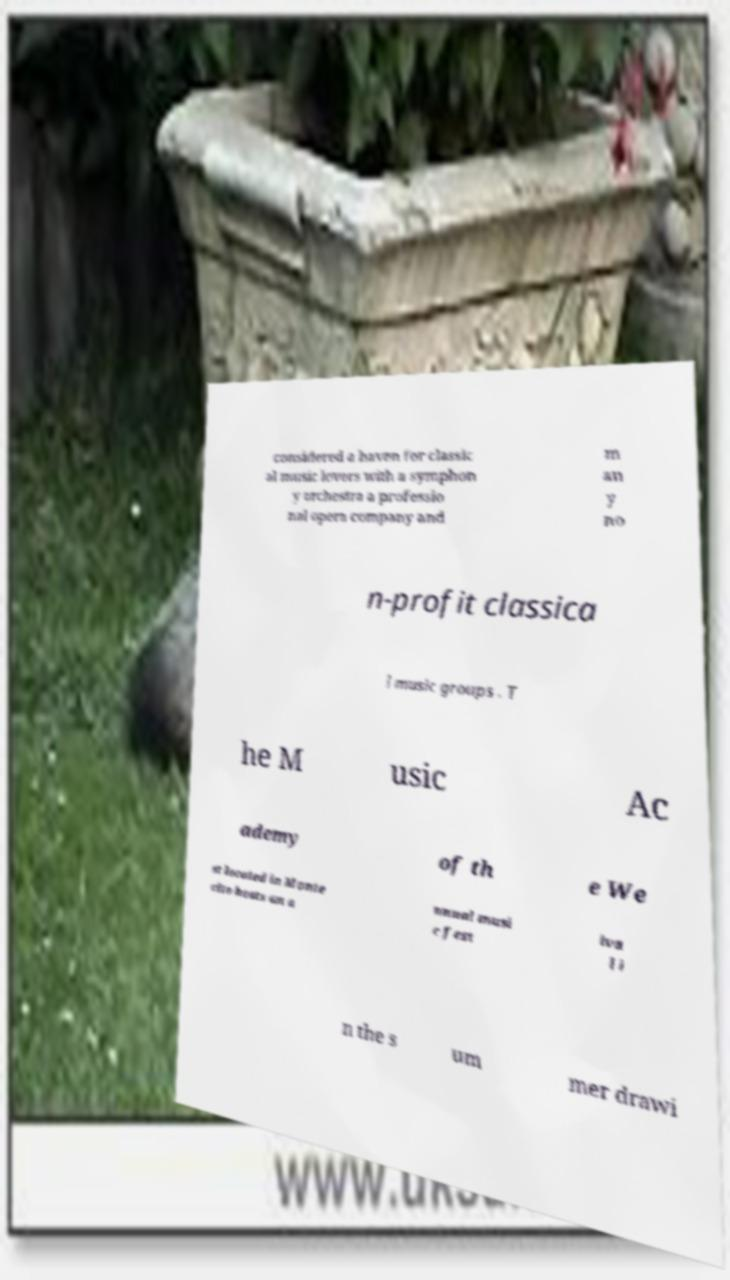There's text embedded in this image that I need extracted. Can you transcribe it verbatim? considered a haven for classic al music lovers with a symphon y orchestra a professio nal opera company and m an y no n-profit classica l music groups . T he M usic Ac ademy of th e We st located in Monte cito hosts an a nnual musi c fest iva l i n the s um mer drawi 